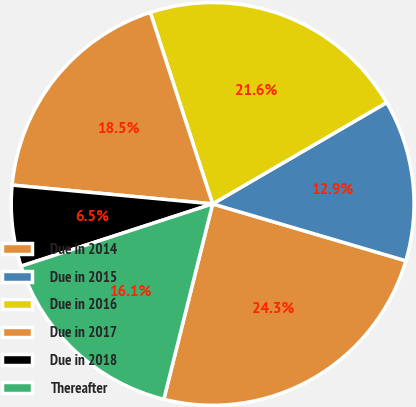<chart> <loc_0><loc_0><loc_500><loc_500><pie_chart><fcel>Due in 2014<fcel>Due in 2015<fcel>Due in 2016<fcel>Due in 2017<fcel>Due in 2018<fcel>Thereafter<nl><fcel>24.34%<fcel>12.95%<fcel>21.62%<fcel>18.5%<fcel>6.49%<fcel>16.1%<nl></chart> 